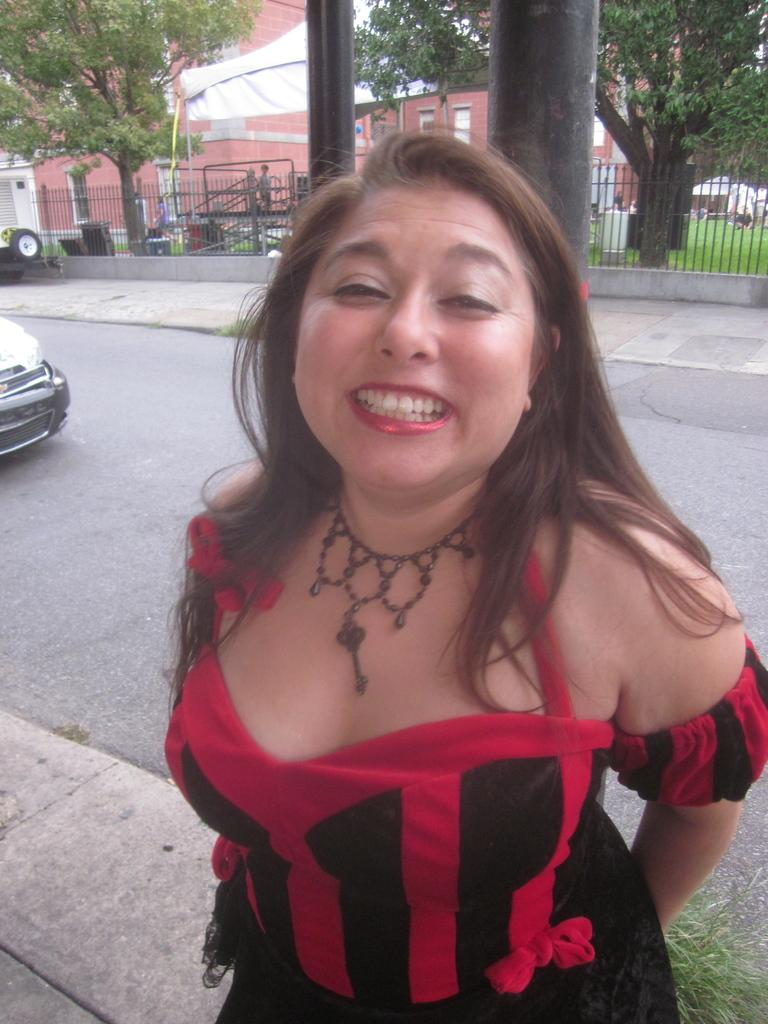What is the woman in the image doing? The woman is standing and smiling in the image. What can be seen on the road in the image? There is a vehicle on the road in the image. What type of architectural feature is present in the image? There are iron grilles in the image. What type of natural element is present in the image? There are trees in the image. How many people are present in the image? There is a group of people in the image. What type of structure is present in the image? There is a building in the image. What type of temporary shelter is present in the image? There is a tent in the image. Where is the lake in the image? There is no lake present in the image. 